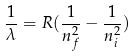<formula> <loc_0><loc_0><loc_500><loc_500>\frac { 1 } { \lambda } = R ( \frac { 1 } { n _ { f } ^ { 2 } } - \frac { 1 } { n _ { i } ^ { 2 } } )</formula> 